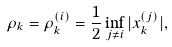<formula> <loc_0><loc_0><loc_500><loc_500>\rho _ { k } = \rho ^ { ( i ) } _ { k } = \frac { 1 } { 2 } \inf _ { j \neq i } | x _ { k } ^ { ( j ) } | ,</formula> 